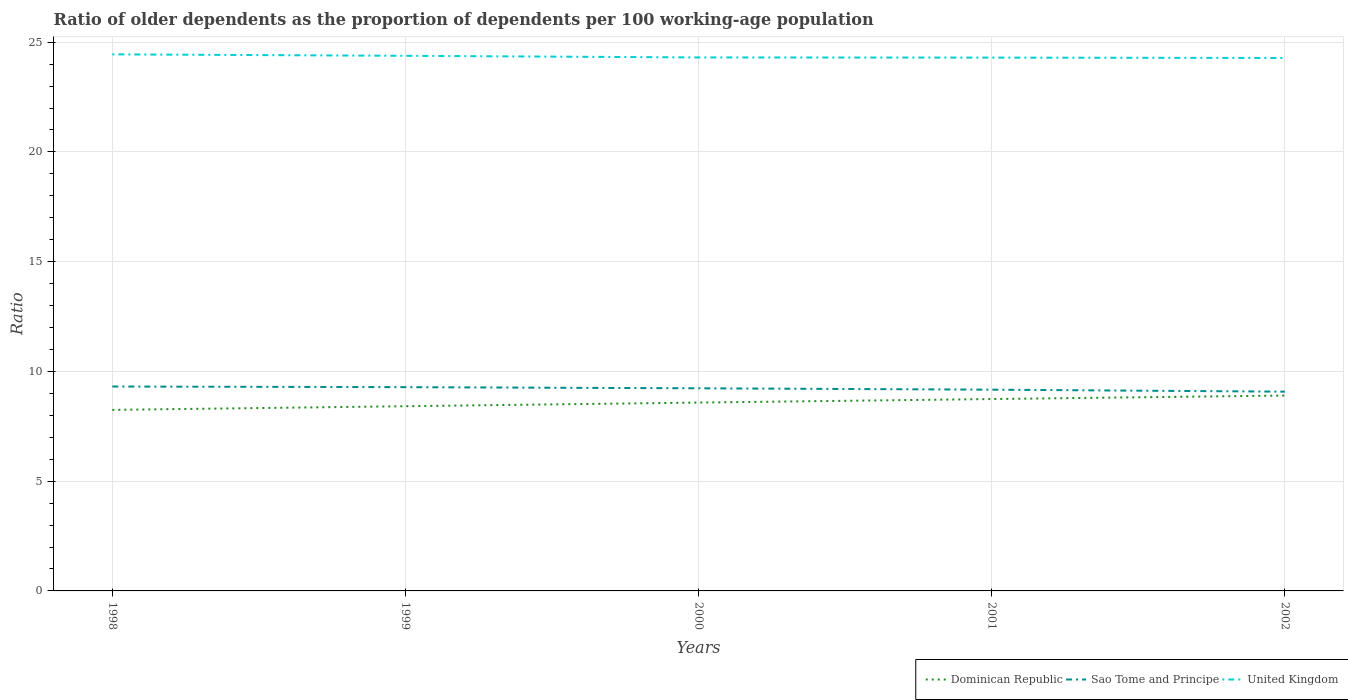How many different coloured lines are there?
Provide a succinct answer. 3. Does the line corresponding to Sao Tome and Principe intersect with the line corresponding to United Kingdom?
Offer a very short reply. No. Across all years, what is the maximum age dependency ratio(old) in United Kingdom?
Provide a short and direct response. 24.28. In which year was the age dependency ratio(old) in United Kingdom maximum?
Make the answer very short. 2002. What is the total age dependency ratio(old) in Sao Tome and Principe in the graph?
Offer a terse response. 0.15. What is the difference between the highest and the second highest age dependency ratio(old) in Sao Tome and Principe?
Keep it short and to the point. 0.24. What is the difference between the highest and the lowest age dependency ratio(old) in Sao Tome and Principe?
Your response must be concise. 3. Is the age dependency ratio(old) in United Kingdom strictly greater than the age dependency ratio(old) in Sao Tome and Principe over the years?
Give a very brief answer. No. What is the difference between two consecutive major ticks on the Y-axis?
Give a very brief answer. 5. Does the graph contain grids?
Your answer should be compact. Yes. How many legend labels are there?
Provide a succinct answer. 3. How are the legend labels stacked?
Provide a succinct answer. Horizontal. What is the title of the graph?
Offer a terse response. Ratio of older dependents as the proportion of dependents per 100 working-age population. What is the label or title of the X-axis?
Make the answer very short. Years. What is the label or title of the Y-axis?
Keep it short and to the point. Ratio. What is the Ratio of Dominican Republic in 1998?
Give a very brief answer. 8.25. What is the Ratio in Sao Tome and Principe in 1998?
Keep it short and to the point. 9.31. What is the Ratio in United Kingdom in 1998?
Make the answer very short. 24.44. What is the Ratio of Dominican Republic in 1999?
Offer a terse response. 8.41. What is the Ratio in Sao Tome and Principe in 1999?
Your response must be concise. 9.28. What is the Ratio in United Kingdom in 1999?
Keep it short and to the point. 24.38. What is the Ratio in Dominican Republic in 2000?
Offer a very short reply. 8.58. What is the Ratio in Sao Tome and Principe in 2000?
Make the answer very short. 9.23. What is the Ratio of United Kingdom in 2000?
Provide a short and direct response. 24.3. What is the Ratio of Dominican Republic in 2001?
Provide a short and direct response. 8.74. What is the Ratio of Sao Tome and Principe in 2001?
Give a very brief answer. 9.17. What is the Ratio of United Kingdom in 2001?
Offer a very short reply. 24.3. What is the Ratio in Dominican Republic in 2002?
Your answer should be very brief. 8.9. What is the Ratio in Sao Tome and Principe in 2002?
Offer a terse response. 9.08. What is the Ratio of United Kingdom in 2002?
Your response must be concise. 24.28. Across all years, what is the maximum Ratio in Dominican Republic?
Ensure brevity in your answer.  8.9. Across all years, what is the maximum Ratio in Sao Tome and Principe?
Your answer should be compact. 9.31. Across all years, what is the maximum Ratio in United Kingdom?
Your answer should be compact. 24.44. Across all years, what is the minimum Ratio in Dominican Republic?
Keep it short and to the point. 8.25. Across all years, what is the minimum Ratio of Sao Tome and Principe?
Make the answer very short. 9.08. Across all years, what is the minimum Ratio of United Kingdom?
Your answer should be very brief. 24.28. What is the total Ratio of Dominican Republic in the graph?
Provide a succinct answer. 42.88. What is the total Ratio in Sao Tome and Principe in the graph?
Provide a succinct answer. 46.07. What is the total Ratio in United Kingdom in the graph?
Provide a short and direct response. 121.7. What is the difference between the Ratio of Dominican Republic in 1998 and that in 1999?
Ensure brevity in your answer.  -0.17. What is the difference between the Ratio of Sao Tome and Principe in 1998 and that in 1999?
Make the answer very short. 0.03. What is the difference between the Ratio of United Kingdom in 1998 and that in 1999?
Provide a succinct answer. 0.07. What is the difference between the Ratio of Dominican Republic in 1998 and that in 2000?
Keep it short and to the point. -0.33. What is the difference between the Ratio of Sao Tome and Principe in 1998 and that in 2000?
Provide a short and direct response. 0.08. What is the difference between the Ratio in United Kingdom in 1998 and that in 2000?
Offer a very short reply. 0.14. What is the difference between the Ratio in Dominican Republic in 1998 and that in 2001?
Keep it short and to the point. -0.49. What is the difference between the Ratio in Sao Tome and Principe in 1998 and that in 2001?
Make the answer very short. 0.14. What is the difference between the Ratio of United Kingdom in 1998 and that in 2001?
Keep it short and to the point. 0.15. What is the difference between the Ratio of Dominican Republic in 1998 and that in 2002?
Keep it short and to the point. -0.65. What is the difference between the Ratio in Sao Tome and Principe in 1998 and that in 2002?
Give a very brief answer. 0.23. What is the difference between the Ratio of United Kingdom in 1998 and that in 2002?
Keep it short and to the point. 0.17. What is the difference between the Ratio in Dominican Republic in 1999 and that in 2000?
Make the answer very short. -0.17. What is the difference between the Ratio of Sao Tome and Principe in 1999 and that in 2000?
Your response must be concise. 0.05. What is the difference between the Ratio of United Kingdom in 1999 and that in 2000?
Make the answer very short. 0.07. What is the difference between the Ratio of Dominican Republic in 1999 and that in 2001?
Your response must be concise. -0.33. What is the difference between the Ratio in Sao Tome and Principe in 1999 and that in 2001?
Give a very brief answer. 0.11. What is the difference between the Ratio in United Kingdom in 1999 and that in 2001?
Your answer should be very brief. 0.08. What is the difference between the Ratio in Dominican Republic in 1999 and that in 2002?
Make the answer very short. -0.49. What is the difference between the Ratio in Sao Tome and Principe in 1999 and that in 2002?
Make the answer very short. 0.21. What is the difference between the Ratio in United Kingdom in 1999 and that in 2002?
Provide a short and direct response. 0.1. What is the difference between the Ratio of Dominican Republic in 2000 and that in 2001?
Ensure brevity in your answer.  -0.16. What is the difference between the Ratio in Sao Tome and Principe in 2000 and that in 2001?
Give a very brief answer. 0.06. What is the difference between the Ratio of United Kingdom in 2000 and that in 2001?
Your answer should be very brief. 0.01. What is the difference between the Ratio of Dominican Republic in 2000 and that in 2002?
Make the answer very short. -0.32. What is the difference between the Ratio of Sao Tome and Principe in 2000 and that in 2002?
Keep it short and to the point. 0.15. What is the difference between the Ratio of United Kingdom in 2000 and that in 2002?
Offer a terse response. 0.02. What is the difference between the Ratio of Dominican Republic in 2001 and that in 2002?
Make the answer very short. -0.16. What is the difference between the Ratio in Sao Tome and Principe in 2001 and that in 2002?
Offer a very short reply. 0.09. What is the difference between the Ratio of United Kingdom in 2001 and that in 2002?
Offer a very short reply. 0.02. What is the difference between the Ratio in Dominican Republic in 1998 and the Ratio in Sao Tome and Principe in 1999?
Your answer should be compact. -1.04. What is the difference between the Ratio in Dominican Republic in 1998 and the Ratio in United Kingdom in 1999?
Offer a very short reply. -16.13. What is the difference between the Ratio in Sao Tome and Principe in 1998 and the Ratio in United Kingdom in 1999?
Offer a terse response. -15.07. What is the difference between the Ratio in Dominican Republic in 1998 and the Ratio in Sao Tome and Principe in 2000?
Make the answer very short. -0.98. What is the difference between the Ratio in Dominican Republic in 1998 and the Ratio in United Kingdom in 2000?
Provide a succinct answer. -16.06. What is the difference between the Ratio in Sao Tome and Principe in 1998 and the Ratio in United Kingdom in 2000?
Your answer should be very brief. -14.99. What is the difference between the Ratio in Dominican Republic in 1998 and the Ratio in Sao Tome and Principe in 2001?
Your answer should be compact. -0.92. What is the difference between the Ratio of Dominican Republic in 1998 and the Ratio of United Kingdom in 2001?
Give a very brief answer. -16.05. What is the difference between the Ratio in Sao Tome and Principe in 1998 and the Ratio in United Kingdom in 2001?
Your response must be concise. -14.98. What is the difference between the Ratio of Dominican Republic in 1998 and the Ratio of Sao Tome and Principe in 2002?
Provide a succinct answer. -0.83. What is the difference between the Ratio in Dominican Republic in 1998 and the Ratio in United Kingdom in 2002?
Offer a terse response. -16.03. What is the difference between the Ratio in Sao Tome and Principe in 1998 and the Ratio in United Kingdom in 2002?
Give a very brief answer. -14.97. What is the difference between the Ratio in Dominican Republic in 1999 and the Ratio in Sao Tome and Principe in 2000?
Your response must be concise. -0.82. What is the difference between the Ratio in Dominican Republic in 1999 and the Ratio in United Kingdom in 2000?
Your answer should be very brief. -15.89. What is the difference between the Ratio in Sao Tome and Principe in 1999 and the Ratio in United Kingdom in 2000?
Offer a terse response. -15.02. What is the difference between the Ratio in Dominican Republic in 1999 and the Ratio in Sao Tome and Principe in 2001?
Ensure brevity in your answer.  -0.75. What is the difference between the Ratio in Dominican Republic in 1999 and the Ratio in United Kingdom in 2001?
Ensure brevity in your answer.  -15.88. What is the difference between the Ratio in Sao Tome and Principe in 1999 and the Ratio in United Kingdom in 2001?
Your answer should be very brief. -15.01. What is the difference between the Ratio in Dominican Republic in 1999 and the Ratio in Sao Tome and Principe in 2002?
Your answer should be very brief. -0.66. What is the difference between the Ratio in Dominican Republic in 1999 and the Ratio in United Kingdom in 2002?
Offer a terse response. -15.86. What is the difference between the Ratio of Sao Tome and Principe in 1999 and the Ratio of United Kingdom in 2002?
Ensure brevity in your answer.  -15. What is the difference between the Ratio of Dominican Republic in 2000 and the Ratio of Sao Tome and Principe in 2001?
Give a very brief answer. -0.59. What is the difference between the Ratio in Dominican Republic in 2000 and the Ratio in United Kingdom in 2001?
Provide a succinct answer. -15.72. What is the difference between the Ratio of Sao Tome and Principe in 2000 and the Ratio of United Kingdom in 2001?
Your answer should be very brief. -15.07. What is the difference between the Ratio in Dominican Republic in 2000 and the Ratio in Sao Tome and Principe in 2002?
Keep it short and to the point. -0.5. What is the difference between the Ratio of Dominican Republic in 2000 and the Ratio of United Kingdom in 2002?
Your answer should be compact. -15.7. What is the difference between the Ratio of Sao Tome and Principe in 2000 and the Ratio of United Kingdom in 2002?
Make the answer very short. -15.05. What is the difference between the Ratio of Dominican Republic in 2001 and the Ratio of Sao Tome and Principe in 2002?
Provide a succinct answer. -0.34. What is the difference between the Ratio of Dominican Republic in 2001 and the Ratio of United Kingdom in 2002?
Ensure brevity in your answer.  -15.54. What is the difference between the Ratio in Sao Tome and Principe in 2001 and the Ratio in United Kingdom in 2002?
Offer a terse response. -15.11. What is the average Ratio of Dominican Republic per year?
Ensure brevity in your answer.  8.58. What is the average Ratio of Sao Tome and Principe per year?
Your response must be concise. 9.21. What is the average Ratio of United Kingdom per year?
Your answer should be very brief. 24.34. In the year 1998, what is the difference between the Ratio in Dominican Republic and Ratio in Sao Tome and Principe?
Keep it short and to the point. -1.06. In the year 1998, what is the difference between the Ratio of Dominican Republic and Ratio of United Kingdom?
Offer a terse response. -16.2. In the year 1998, what is the difference between the Ratio in Sao Tome and Principe and Ratio in United Kingdom?
Your answer should be very brief. -15.13. In the year 1999, what is the difference between the Ratio of Dominican Republic and Ratio of Sao Tome and Principe?
Offer a terse response. -0.87. In the year 1999, what is the difference between the Ratio in Dominican Republic and Ratio in United Kingdom?
Provide a succinct answer. -15.96. In the year 1999, what is the difference between the Ratio of Sao Tome and Principe and Ratio of United Kingdom?
Your answer should be compact. -15.1. In the year 2000, what is the difference between the Ratio in Dominican Republic and Ratio in Sao Tome and Principe?
Your answer should be very brief. -0.65. In the year 2000, what is the difference between the Ratio of Dominican Republic and Ratio of United Kingdom?
Your response must be concise. -15.72. In the year 2000, what is the difference between the Ratio in Sao Tome and Principe and Ratio in United Kingdom?
Your response must be concise. -15.07. In the year 2001, what is the difference between the Ratio of Dominican Republic and Ratio of Sao Tome and Principe?
Offer a terse response. -0.43. In the year 2001, what is the difference between the Ratio in Dominican Republic and Ratio in United Kingdom?
Keep it short and to the point. -15.56. In the year 2001, what is the difference between the Ratio in Sao Tome and Principe and Ratio in United Kingdom?
Make the answer very short. -15.13. In the year 2002, what is the difference between the Ratio in Dominican Republic and Ratio in Sao Tome and Principe?
Your answer should be compact. -0.18. In the year 2002, what is the difference between the Ratio in Dominican Republic and Ratio in United Kingdom?
Provide a succinct answer. -15.38. In the year 2002, what is the difference between the Ratio of Sao Tome and Principe and Ratio of United Kingdom?
Offer a very short reply. -15.2. What is the ratio of the Ratio of Dominican Republic in 1998 to that in 1999?
Provide a succinct answer. 0.98. What is the ratio of the Ratio of United Kingdom in 1998 to that in 1999?
Your response must be concise. 1. What is the ratio of the Ratio in Dominican Republic in 1998 to that in 2000?
Keep it short and to the point. 0.96. What is the ratio of the Ratio of Sao Tome and Principe in 1998 to that in 2000?
Offer a very short reply. 1.01. What is the ratio of the Ratio of Dominican Republic in 1998 to that in 2001?
Give a very brief answer. 0.94. What is the ratio of the Ratio of Sao Tome and Principe in 1998 to that in 2001?
Offer a terse response. 1.02. What is the ratio of the Ratio in Dominican Republic in 1998 to that in 2002?
Offer a very short reply. 0.93. What is the ratio of the Ratio of Sao Tome and Principe in 1998 to that in 2002?
Your response must be concise. 1.03. What is the ratio of the Ratio in United Kingdom in 1998 to that in 2002?
Give a very brief answer. 1.01. What is the ratio of the Ratio in Dominican Republic in 1999 to that in 2000?
Your response must be concise. 0.98. What is the ratio of the Ratio in Sao Tome and Principe in 1999 to that in 2000?
Your answer should be compact. 1.01. What is the ratio of the Ratio of Dominican Republic in 1999 to that in 2001?
Your answer should be compact. 0.96. What is the ratio of the Ratio of Sao Tome and Principe in 1999 to that in 2001?
Your answer should be compact. 1.01. What is the ratio of the Ratio in Dominican Republic in 1999 to that in 2002?
Ensure brevity in your answer.  0.95. What is the ratio of the Ratio in Sao Tome and Principe in 1999 to that in 2002?
Offer a terse response. 1.02. What is the ratio of the Ratio in United Kingdom in 1999 to that in 2002?
Your answer should be compact. 1. What is the ratio of the Ratio in Dominican Republic in 2000 to that in 2001?
Your answer should be compact. 0.98. What is the ratio of the Ratio in Sao Tome and Principe in 2000 to that in 2001?
Your answer should be very brief. 1.01. What is the ratio of the Ratio in United Kingdom in 2000 to that in 2001?
Your answer should be very brief. 1. What is the ratio of the Ratio of Dominican Republic in 2000 to that in 2002?
Ensure brevity in your answer.  0.96. What is the ratio of the Ratio of Sao Tome and Principe in 2000 to that in 2002?
Provide a succinct answer. 1.02. What is the ratio of the Ratio of United Kingdom in 2000 to that in 2002?
Your answer should be very brief. 1. What is the ratio of the Ratio in Dominican Republic in 2001 to that in 2002?
Offer a very short reply. 0.98. What is the ratio of the Ratio of United Kingdom in 2001 to that in 2002?
Your answer should be compact. 1. What is the difference between the highest and the second highest Ratio of Dominican Republic?
Your answer should be compact. 0.16. What is the difference between the highest and the second highest Ratio in Sao Tome and Principe?
Your answer should be very brief. 0.03. What is the difference between the highest and the second highest Ratio of United Kingdom?
Ensure brevity in your answer.  0.07. What is the difference between the highest and the lowest Ratio in Dominican Republic?
Keep it short and to the point. 0.65. What is the difference between the highest and the lowest Ratio of Sao Tome and Principe?
Your answer should be compact. 0.23. What is the difference between the highest and the lowest Ratio of United Kingdom?
Provide a succinct answer. 0.17. 